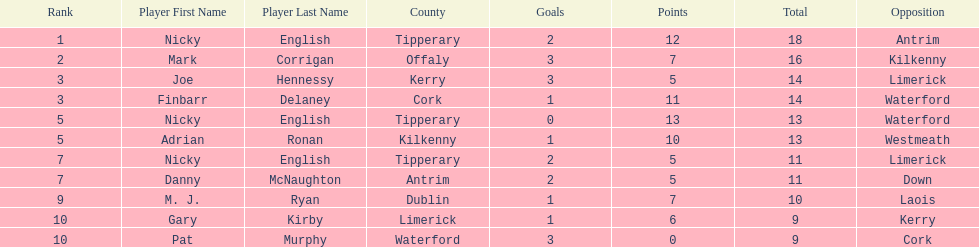What was the combined total of nicky english and mark corrigan? 34. 